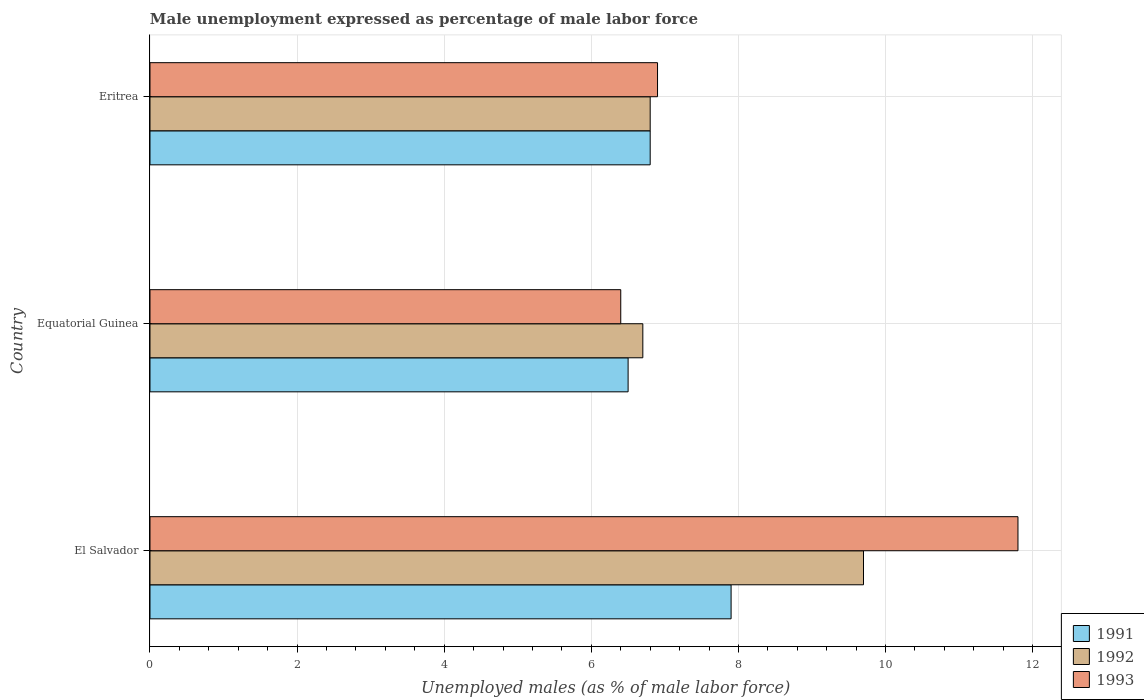Are the number of bars per tick equal to the number of legend labels?
Keep it short and to the point. Yes. How many bars are there on the 3rd tick from the bottom?
Make the answer very short. 3. What is the label of the 3rd group of bars from the top?
Ensure brevity in your answer.  El Salvador. What is the unemployment in males in in 1992 in Eritrea?
Your answer should be compact. 6.8. Across all countries, what is the maximum unemployment in males in in 1991?
Keep it short and to the point. 7.9. Across all countries, what is the minimum unemployment in males in in 1993?
Give a very brief answer. 6.4. In which country was the unemployment in males in in 1992 maximum?
Make the answer very short. El Salvador. In which country was the unemployment in males in in 1991 minimum?
Offer a very short reply. Equatorial Guinea. What is the total unemployment in males in in 1993 in the graph?
Your answer should be very brief. 25.1. What is the difference between the unemployment in males in in 1991 in El Salvador and that in Equatorial Guinea?
Provide a short and direct response. 1.4. What is the difference between the unemployment in males in in 1991 in Equatorial Guinea and the unemployment in males in in 1993 in El Salvador?
Your answer should be very brief. -5.3. What is the average unemployment in males in in 1991 per country?
Provide a short and direct response. 7.07. What is the difference between the unemployment in males in in 1992 and unemployment in males in in 1991 in Equatorial Guinea?
Make the answer very short. 0.2. What is the ratio of the unemployment in males in in 1992 in Equatorial Guinea to that in Eritrea?
Ensure brevity in your answer.  0.99. Is the unemployment in males in in 1993 in El Salvador less than that in Equatorial Guinea?
Your response must be concise. No. Is the difference between the unemployment in males in in 1992 in El Salvador and Equatorial Guinea greater than the difference between the unemployment in males in in 1991 in El Salvador and Equatorial Guinea?
Offer a terse response. Yes. What is the difference between the highest and the second highest unemployment in males in in 1993?
Give a very brief answer. 4.9. What is the difference between the highest and the lowest unemployment in males in in 1991?
Give a very brief answer. 1.4. What does the 2nd bar from the top in Eritrea represents?
Give a very brief answer. 1992. What does the 1st bar from the bottom in El Salvador represents?
Your answer should be very brief. 1991. How many countries are there in the graph?
Provide a succinct answer. 3. Are the values on the major ticks of X-axis written in scientific E-notation?
Your answer should be compact. No. Does the graph contain any zero values?
Provide a short and direct response. No. Does the graph contain grids?
Offer a very short reply. Yes. How many legend labels are there?
Offer a terse response. 3. How are the legend labels stacked?
Your answer should be very brief. Vertical. What is the title of the graph?
Your answer should be very brief. Male unemployment expressed as percentage of male labor force. What is the label or title of the X-axis?
Give a very brief answer. Unemployed males (as % of male labor force). What is the label or title of the Y-axis?
Offer a terse response. Country. What is the Unemployed males (as % of male labor force) of 1991 in El Salvador?
Make the answer very short. 7.9. What is the Unemployed males (as % of male labor force) of 1992 in El Salvador?
Keep it short and to the point. 9.7. What is the Unemployed males (as % of male labor force) in 1993 in El Salvador?
Offer a very short reply. 11.8. What is the Unemployed males (as % of male labor force) of 1991 in Equatorial Guinea?
Provide a short and direct response. 6.5. What is the Unemployed males (as % of male labor force) in 1992 in Equatorial Guinea?
Ensure brevity in your answer.  6.7. What is the Unemployed males (as % of male labor force) of 1993 in Equatorial Guinea?
Your answer should be very brief. 6.4. What is the Unemployed males (as % of male labor force) in 1991 in Eritrea?
Your response must be concise. 6.8. What is the Unemployed males (as % of male labor force) in 1992 in Eritrea?
Offer a very short reply. 6.8. What is the Unemployed males (as % of male labor force) of 1993 in Eritrea?
Offer a very short reply. 6.9. Across all countries, what is the maximum Unemployed males (as % of male labor force) in 1991?
Your response must be concise. 7.9. Across all countries, what is the maximum Unemployed males (as % of male labor force) in 1992?
Ensure brevity in your answer.  9.7. Across all countries, what is the maximum Unemployed males (as % of male labor force) of 1993?
Give a very brief answer. 11.8. Across all countries, what is the minimum Unemployed males (as % of male labor force) in 1992?
Your answer should be very brief. 6.7. Across all countries, what is the minimum Unemployed males (as % of male labor force) in 1993?
Keep it short and to the point. 6.4. What is the total Unemployed males (as % of male labor force) of 1991 in the graph?
Your response must be concise. 21.2. What is the total Unemployed males (as % of male labor force) of 1992 in the graph?
Provide a short and direct response. 23.2. What is the total Unemployed males (as % of male labor force) of 1993 in the graph?
Provide a short and direct response. 25.1. What is the difference between the Unemployed males (as % of male labor force) of 1991 in El Salvador and that in Equatorial Guinea?
Give a very brief answer. 1.4. What is the difference between the Unemployed males (as % of male labor force) in 1993 in El Salvador and that in Equatorial Guinea?
Ensure brevity in your answer.  5.4. What is the difference between the Unemployed males (as % of male labor force) in 1991 in El Salvador and that in Eritrea?
Offer a terse response. 1.1. What is the difference between the Unemployed males (as % of male labor force) of 1992 in El Salvador and that in Eritrea?
Give a very brief answer. 2.9. What is the difference between the Unemployed males (as % of male labor force) of 1993 in El Salvador and that in Eritrea?
Offer a very short reply. 4.9. What is the difference between the Unemployed males (as % of male labor force) of 1991 in Equatorial Guinea and that in Eritrea?
Offer a very short reply. -0.3. What is the difference between the Unemployed males (as % of male labor force) of 1991 in El Salvador and the Unemployed males (as % of male labor force) of 1993 in Equatorial Guinea?
Your answer should be very brief. 1.5. What is the difference between the Unemployed males (as % of male labor force) in 1992 in El Salvador and the Unemployed males (as % of male labor force) in 1993 in Equatorial Guinea?
Provide a succinct answer. 3.3. What is the difference between the Unemployed males (as % of male labor force) in 1991 in El Salvador and the Unemployed males (as % of male labor force) in 1992 in Eritrea?
Ensure brevity in your answer.  1.1. What is the difference between the Unemployed males (as % of male labor force) of 1992 in El Salvador and the Unemployed males (as % of male labor force) of 1993 in Eritrea?
Your answer should be compact. 2.8. What is the difference between the Unemployed males (as % of male labor force) in 1991 in Equatorial Guinea and the Unemployed males (as % of male labor force) in 1992 in Eritrea?
Make the answer very short. -0.3. What is the difference between the Unemployed males (as % of male labor force) in 1991 in Equatorial Guinea and the Unemployed males (as % of male labor force) in 1993 in Eritrea?
Your answer should be very brief. -0.4. What is the average Unemployed males (as % of male labor force) of 1991 per country?
Your answer should be very brief. 7.07. What is the average Unemployed males (as % of male labor force) of 1992 per country?
Give a very brief answer. 7.73. What is the average Unemployed males (as % of male labor force) of 1993 per country?
Offer a very short reply. 8.37. What is the difference between the Unemployed males (as % of male labor force) in 1991 and Unemployed males (as % of male labor force) in 1992 in El Salvador?
Your answer should be very brief. -1.8. What is the difference between the Unemployed males (as % of male labor force) of 1991 and Unemployed males (as % of male labor force) of 1993 in El Salvador?
Provide a succinct answer. -3.9. What is the difference between the Unemployed males (as % of male labor force) of 1992 and Unemployed males (as % of male labor force) of 1993 in El Salvador?
Offer a very short reply. -2.1. What is the difference between the Unemployed males (as % of male labor force) in 1991 and Unemployed males (as % of male labor force) in 1992 in Equatorial Guinea?
Your answer should be very brief. -0.2. What is the difference between the Unemployed males (as % of male labor force) in 1992 and Unemployed males (as % of male labor force) in 1993 in Equatorial Guinea?
Your response must be concise. 0.3. What is the difference between the Unemployed males (as % of male labor force) of 1991 and Unemployed males (as % of male labor force) of 1992 in Eritrea?
Your answer should be compact. 0. What is the difference between the Unemployed males (as % of male labor force) in 1992 and Unemployed males (as % of male labor force) in 1993 in Eritrea?
Give a very brief answer. -0.1. What is the ratio of the Unemployed males (as % of male labor force) of 1991 in El Salvador to that in Equatorial Guinea?
Provide a succinct answer. 1.22. What is the ratio of the Unemployed males (as % of male labor force) in 1992 in El Salvador to that in Equatorial Guinea?
Your answer should be compact. 1.45. What is the ratio of the Unemployed males (as % of male labor force) in 1993 in El Salvador to that in Equatorial Guinea?
Offer a terse response. 1.84. What is the ratio of the Unemployed males (as % of male labor force) of 1991 in El Salvador to that in Eritrea?
Offer a very short reply. 1.16. What is the ratio of the Unemployed males (as % of male labor force) in 1992 in El Salvador to that in Eritrea?
Provide a short and direct response. 1.43. What is the ratio of the Unemployed males (as % of male labor force) of 1993 in El Salvador to that in Eritrea?
Provide a succinct answer. 1.71. What is the ratio of the Unemployed males (as % of male labor force) in 1991 in Equatorial Guinea to that in Eritrea?
Your response must be concise. 0.96. What is the ratio of the Unemployed males (as % of male labor force) of 1992 in Equatorial Guinea to that in Eritrea?
Ensure brevity in your answer.  0.99. What is the ratio of the Unemployed males (as % of male labor force) of 1993 in Equatorial Guinea to that in Eritrea?
Offer a very short reply. 0.93. What is the difference between the highest and the second highest Unemployed males (as % of male labor force) in 1992?
Offer a terse response. 2.9. What is the difference between the highest and the second highest Unemployed males (as % of male labor force) of 1993?
Your response must be concise. 4.9. What is the difference between the highest and the lowest Unemployed males (as % of male labor force) of 1992?
Offer a very short reply. 3. 